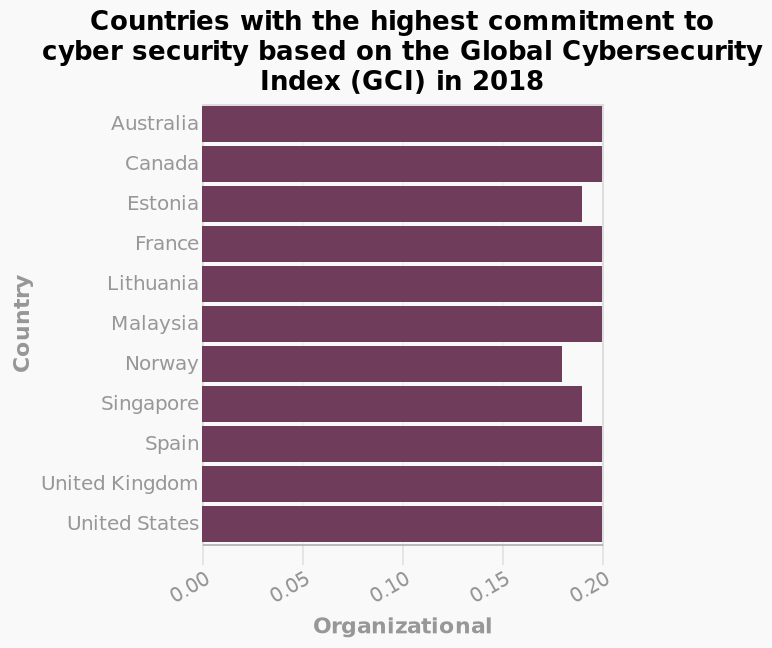<image>
What does the bar diagram show?  The bar diagram shows the countries with the highest commitment to cyber security based on the Global Cybersecurity Index (GCI) in 2018. please summary the statistics and relations of the chart The majority of countries shown on the chart share the same high amount of commitment to cyber security. Norway shows the lowest amount of commitment to cyber security. Which country has the most expensive rate for A4 paper?  Norway. 